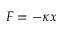<formula> <loc_0><loc_0><loc_500><loc_500>F = - \kappa x</formula> 